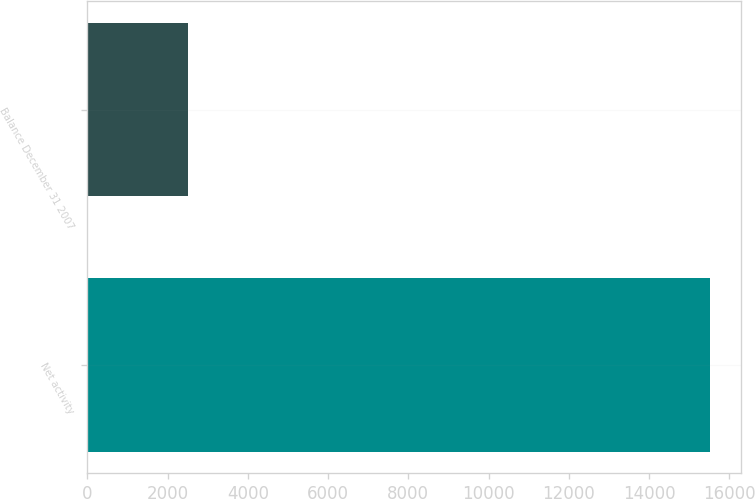<chart> <loc_0><loc_0><loc_500><loc_500><bar_chart><fcel>Net activity<fcel>Balance December 31 2007<nl><fcel>15508<fcel>2511<nl></chart> 